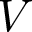Convert formula to latex. <formula><loc_0><loc_0><loc_500><loc_500>V</formula> 